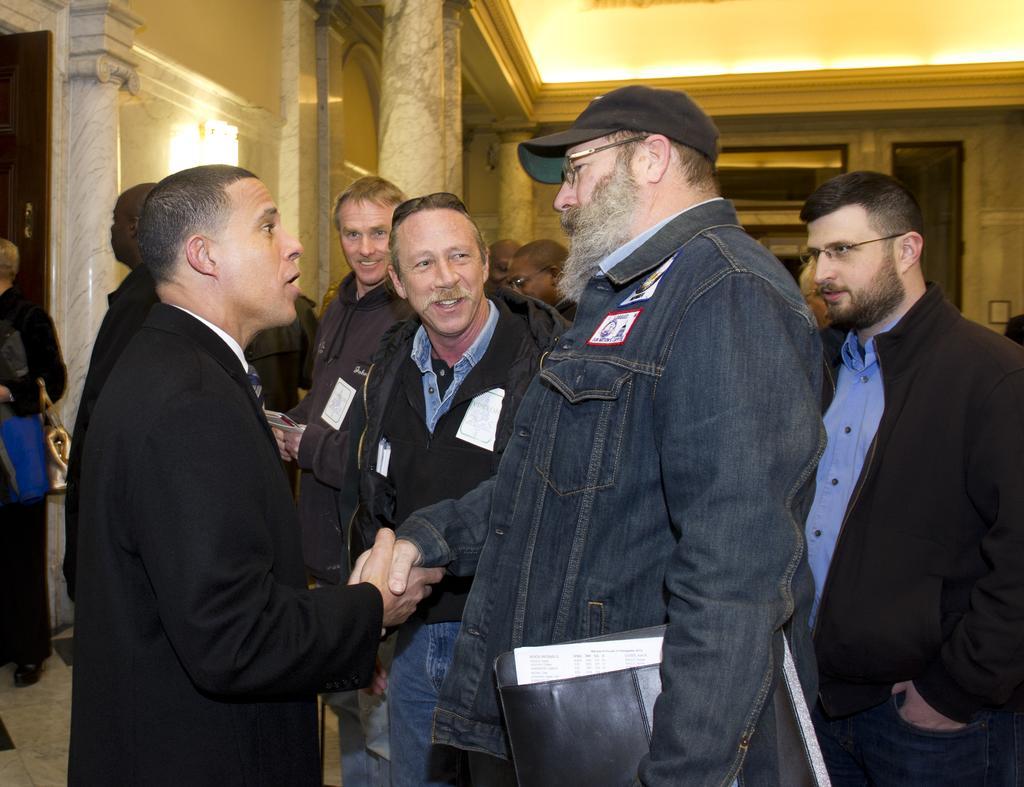Can you describe this image briefly? In the center of the image we can see some people are standing and two men are talking and shaking hands each other and a man is holding a file and wearing a cap. In the background of the image we can see the wall, pillars, lights. At the top of the image we can see the roof. In the bottom left corner we can see the floor. 